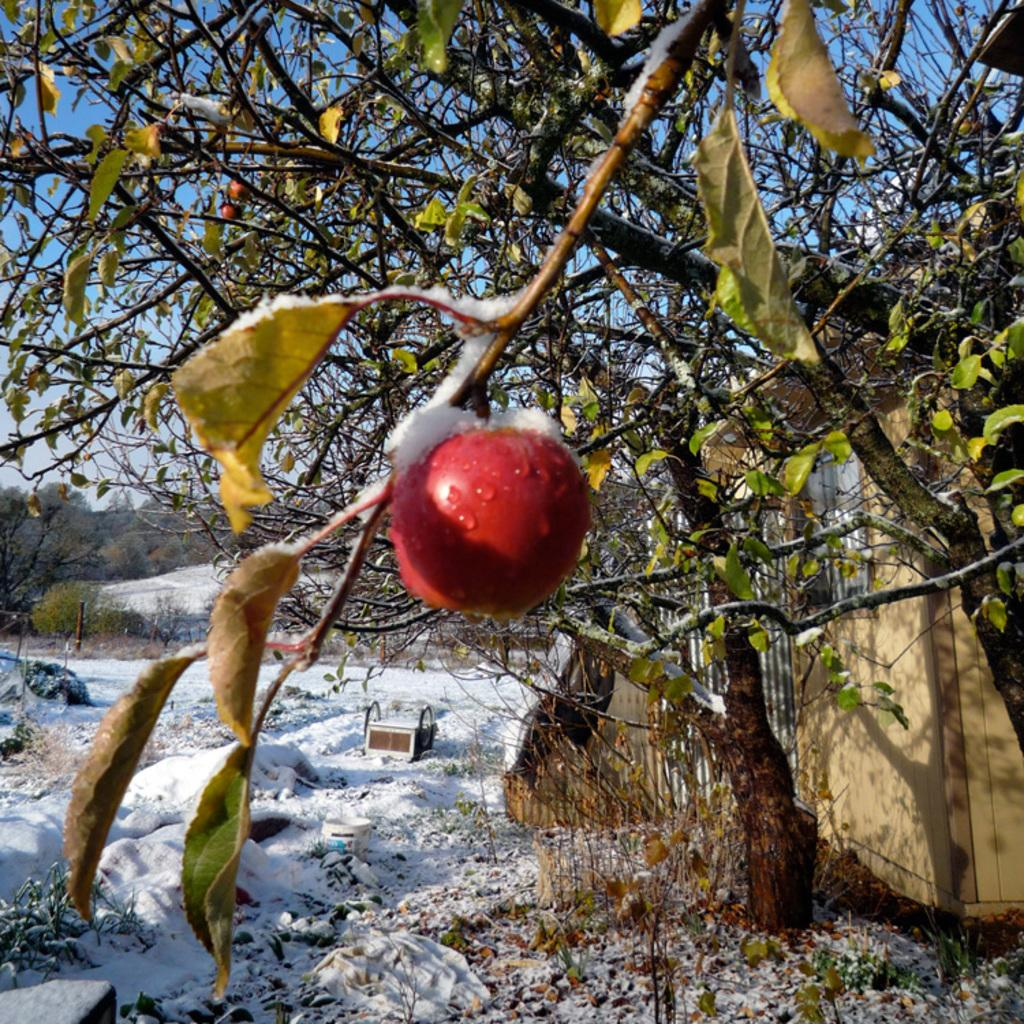What is located in the foreground of the image? There is an apple and trees in the foreground of the image. What can be seen in the background of the image? There is a house, trees, mountains, and poles in the background of the image. What is the condition of the ground at the bottom of the image? There is snow and dry leaves at the bottom of the image. What color is the ink on the sweater in the image? There is no sweater present in the image, and therefore no ink to describe. How many bites have been taken out of the apple in the image? The image does not show any bites taken out of the apple, so it cannot be determined. 